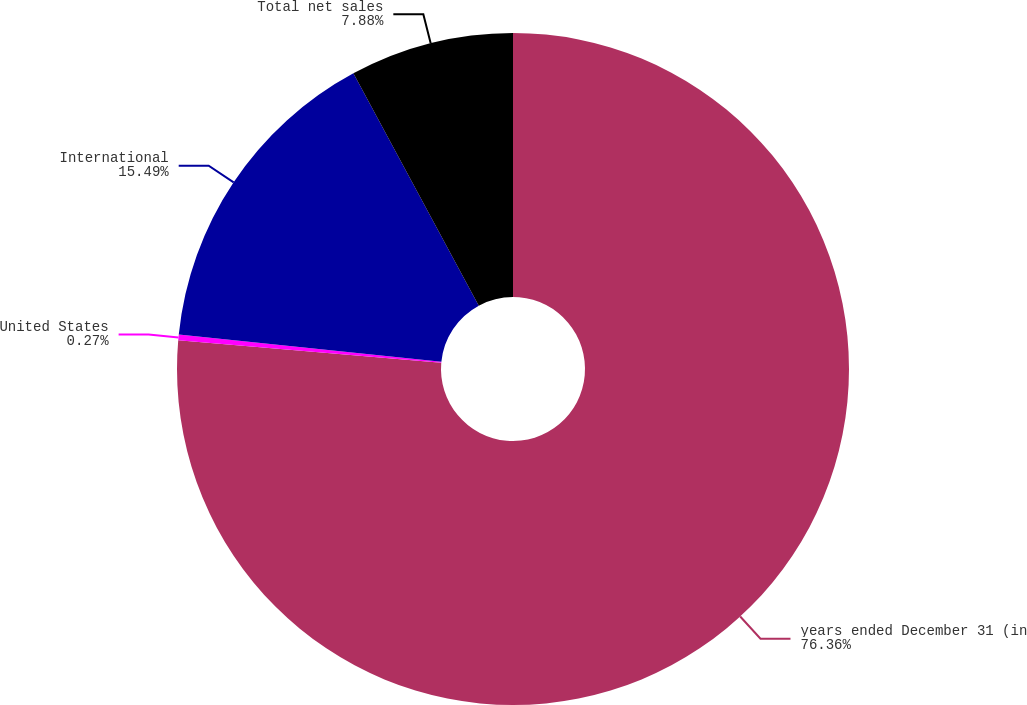Convert chart. <chart><loc_0><loc_0><loc_500><loc_500><pie_chart><fcel>years ended December 31 (in<fcel>United States<fcel>International<fcel>Total net sales<nl><fcel>76.37%<fcel>0.27%<fcel>15.49%<fcel>7.88%<nl></chart> 